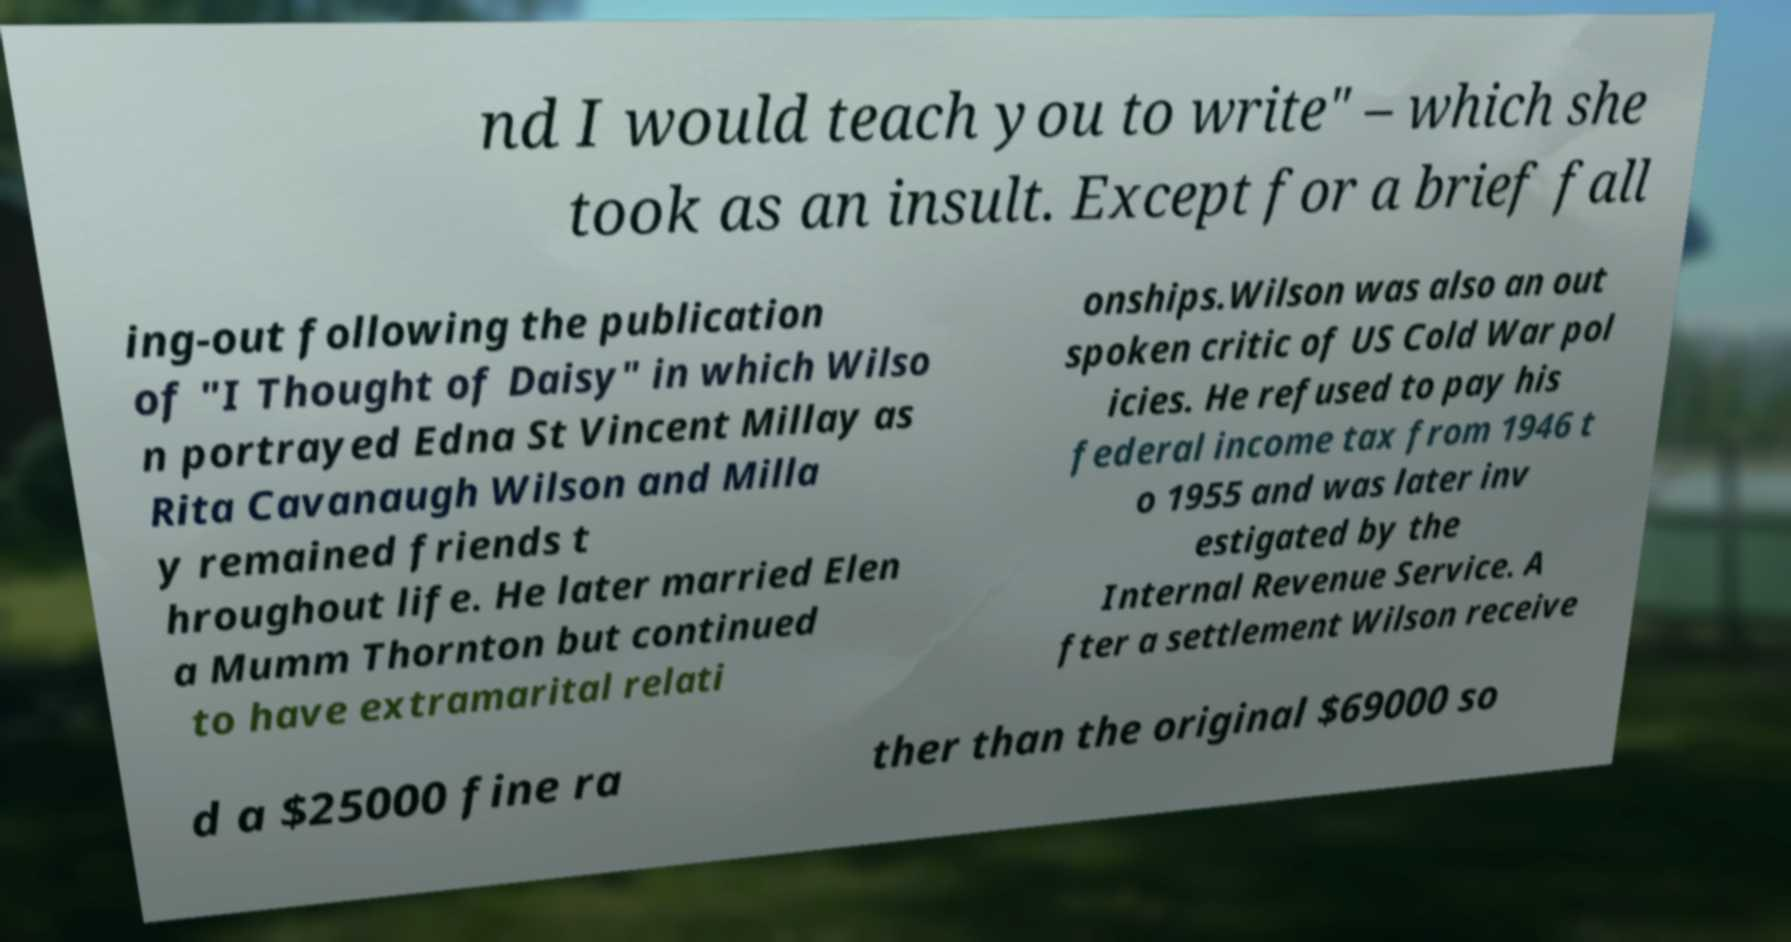I need the written content from this picture converted into text. Can you do that? nd I would teach you to write" – which she took as an insult. Except for a brief fall ing-out following the publication of "I Thought of Daisy" in which Wilso n portrayed Edna St Vincent Millay as Rita Cavanaugh Wilson and Milla y remained friends t hroughout life. He later married Elen a Mumm Thornton but continued to have extramarital relati onships.Wilson was also an out spoken critic of US Cold War pol icies. He refused to pay his federal income tax from 1946 t o 1955 and was later inv estigated by the Internal Revenue Service. A fter a settlement Wilson receive d a $25000 fine ra ther than the original $69000 so 